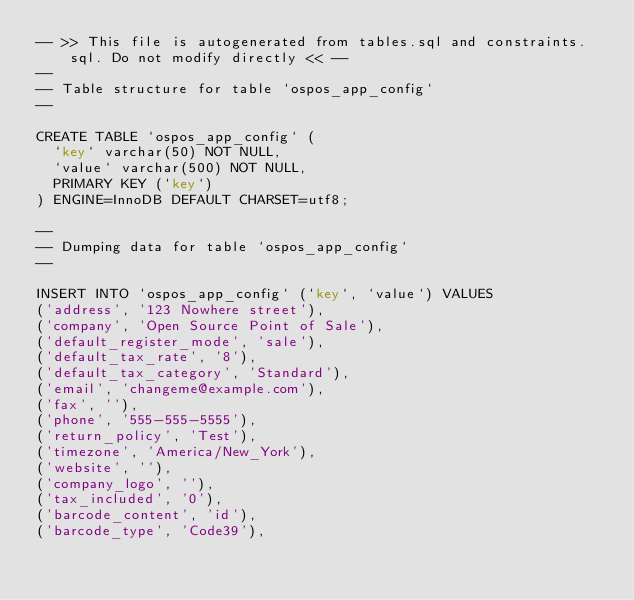<code> <loc_0><loc_0><loc_500><loc_500><_SQL_>-- >> This file is autogenerated from tables.sql and constraints.sql. Do not modify directly << --
--
-- Table structure for table `ospos_app_config`
--

CREATE TABLE `ospos_app_config` (
  `key` varchar(50) NOT NULL,
  `value` varchar(500) NOT NULL,
  PRIMARY KEY (`key`)
) ENGINE=InnoDB DEFAULT CHARSET=utf8;

--
-- Dumping data for table `ospos_app_config`
--

INSERT INTO `ospos_app_config` (`key`, `value`) VALUES
('address', '123 Nowhere street'),
('company', 'Open Source Point of Sale'),
('default_register_mode', 'sale'),
('default_tax_rate', '8'),
('default_tax_category', 'Standard'),
('email', 'changeme@example.com'),
('fax', ''),
('phone', '555-555-5555'),
('return_policy', 'Test'),
('timezone', 'America/New_York'),
('website', ''),
('company_logo', ''),
('tax_included', '0'),
('barcode_content', 'id'),
('barcode_type', 'Code39'),</code> 